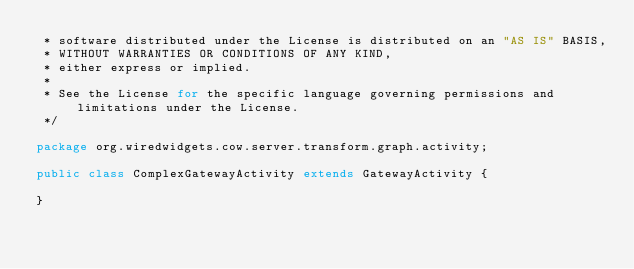<code> <loc_0><loc_0><loc_500><loc_500><_Java_> * software distributed under the License is distributed on an "AS IS" BASIS,
 * WITHOUT WARRANTIES OR CONDITIONS OF ANY KIND,
 * either express or implied.
 *
 * See the License for the specific language governing permissions and limitations under the License.
 */

package org.wiredwidgets.cow.server.transform.graph.activity;

public class ComplexGatewayActivity extends GatewayActivity {

}
</code> 